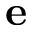<formula> <loc_0><loc_0><loc_500><loc_500>e</formula> 